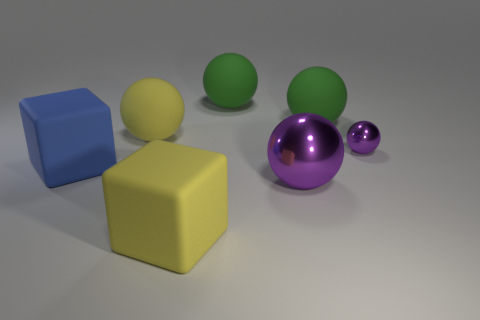How many large gray metallic blocks are there?
Your response must be concise. 0. There is a big ball in front of the blue matte thing; what is it made of?
Provide a short and direct response. Metal. There is a big metallic ball; are there any blue matte things right of it?
Keep it short and to the point. No. Is the blue thing the same size as the yellow ball?
Offer a very short reply. Yes. How many spheres have the same material as the yellow block?
Provide a succinct answer. 3. What size is the cube that is to the left of the yellow rubber object in front of the tiny purple ball?
Give a very brief answer. Large. The matte object that is in front of the small purple shiny object and on the right side of the big blue rubber object is what color?
Make the answer very short. Yellow. Is the shape of the big purple object the same as the big blue thing?
Keep it short and to the point. No. There is another sphere that is the same color as the tiny sphere; what is its size?
Provide a succinct answer. Large. There is a yellow matte object that is in front of the object that is on the left side of the large yellow sphere; what is its shape?
Ensure brevity in your answer.  Cube. 